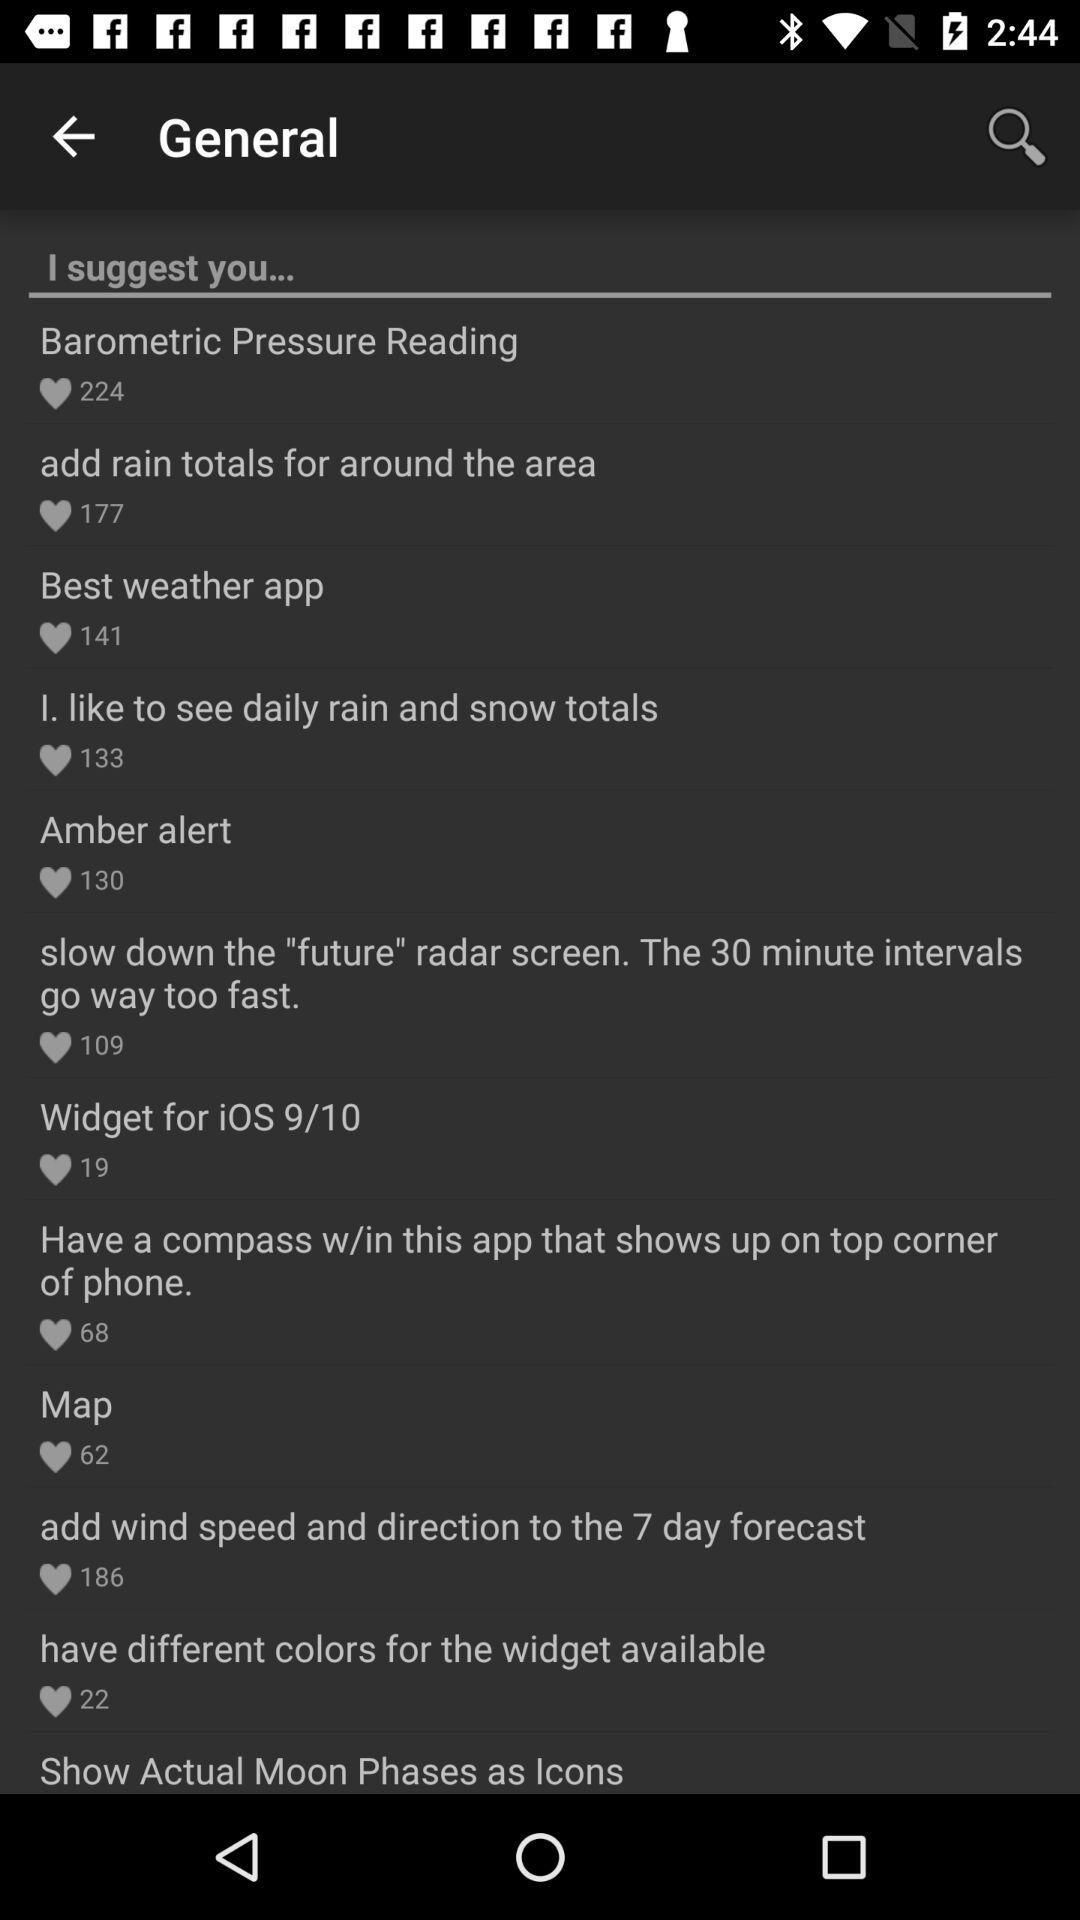How many people liked the "add rain totals for around the area"? It is liked by 177 people. 